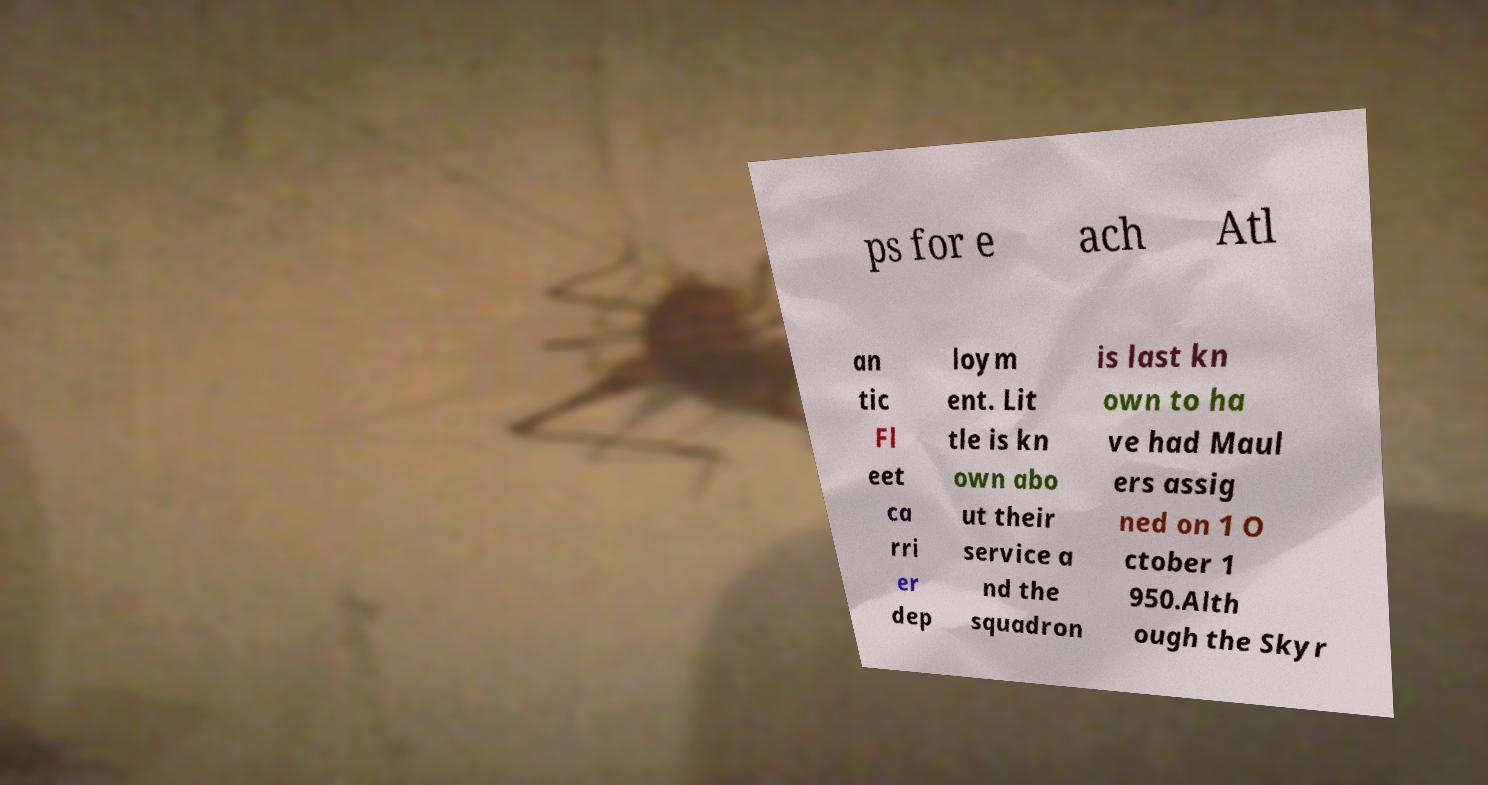Can you accurately transcribe the text from the provided image for me? ps for e ach Atl an tic Fl eet ca rri er dep loym ent. Lit tle is kn own abo ut their service a nd the squadron is last kn own to ha ve had Maul ers assig ned on 1 O ctober 1 950.Alth ough the Skyr 